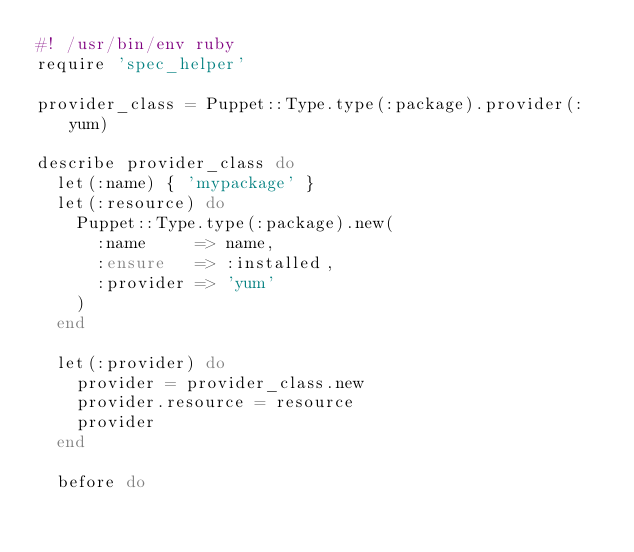Convert code to text. <code><loc_0><loc_0><loc_500><loc_500><_Ruby_>#! /usr/bin/env ruby
require 'spec_helper'

provider_class = Puppet::Type.type(:package).provider(:yum)

describe provider_class do
  let(:name) { 'mypackage' }
  let(:resource) do
    Puppet::Type.type(:package).new(
      :name     => name,
      :ensure   => :installed,
      :provider => 'yum'
    )
  end

  let(:provider) do
    provider = provider_class.new
    provider.resource = resource
    provider
  end

  before do</code> 